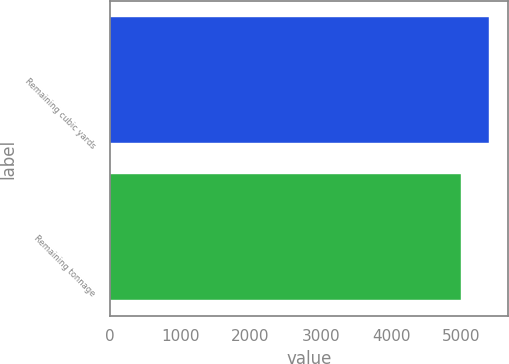Convert chart to OTSL. <chart><loc_0><loc_0><loc_500><loc_500><bar_chart><fcel>Remaining cubic yards<fcel>Remaining tonnage<nl><fcel>5393<fcel>4994<nl></chart> 